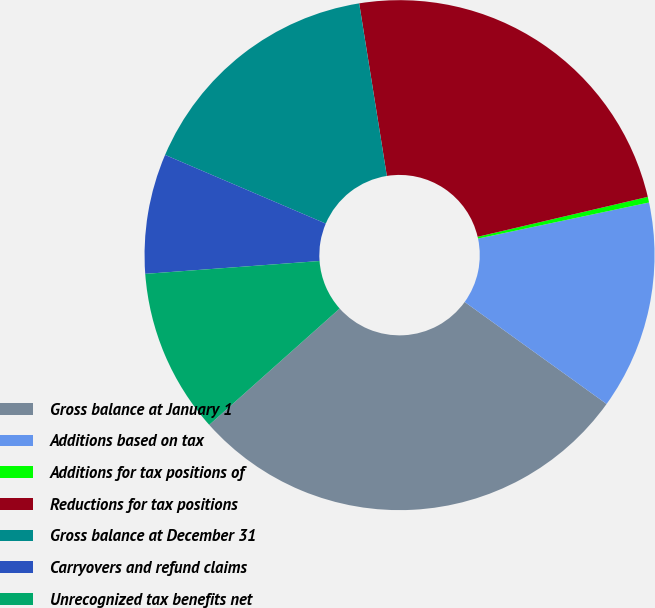<chart> <loc_0><loc_0><loc_500><loc_500><pie_chart><fcel>Gross balance at January 1<fcel>Additions based on tax<fcel>Additions for tax positions of<fcel>Reductions for tax positions<fcel>Gross balance at December 31<fcel>Carryovers and refund claims<fcel>Unrecognized tax benefits net<nl><fcel>28.49%<fcel>13.23%<fcel>0.36%<fcel>23.86%<fcel>16.04%<fcel>7.6%<fcel>10.42%<nl></chart> 